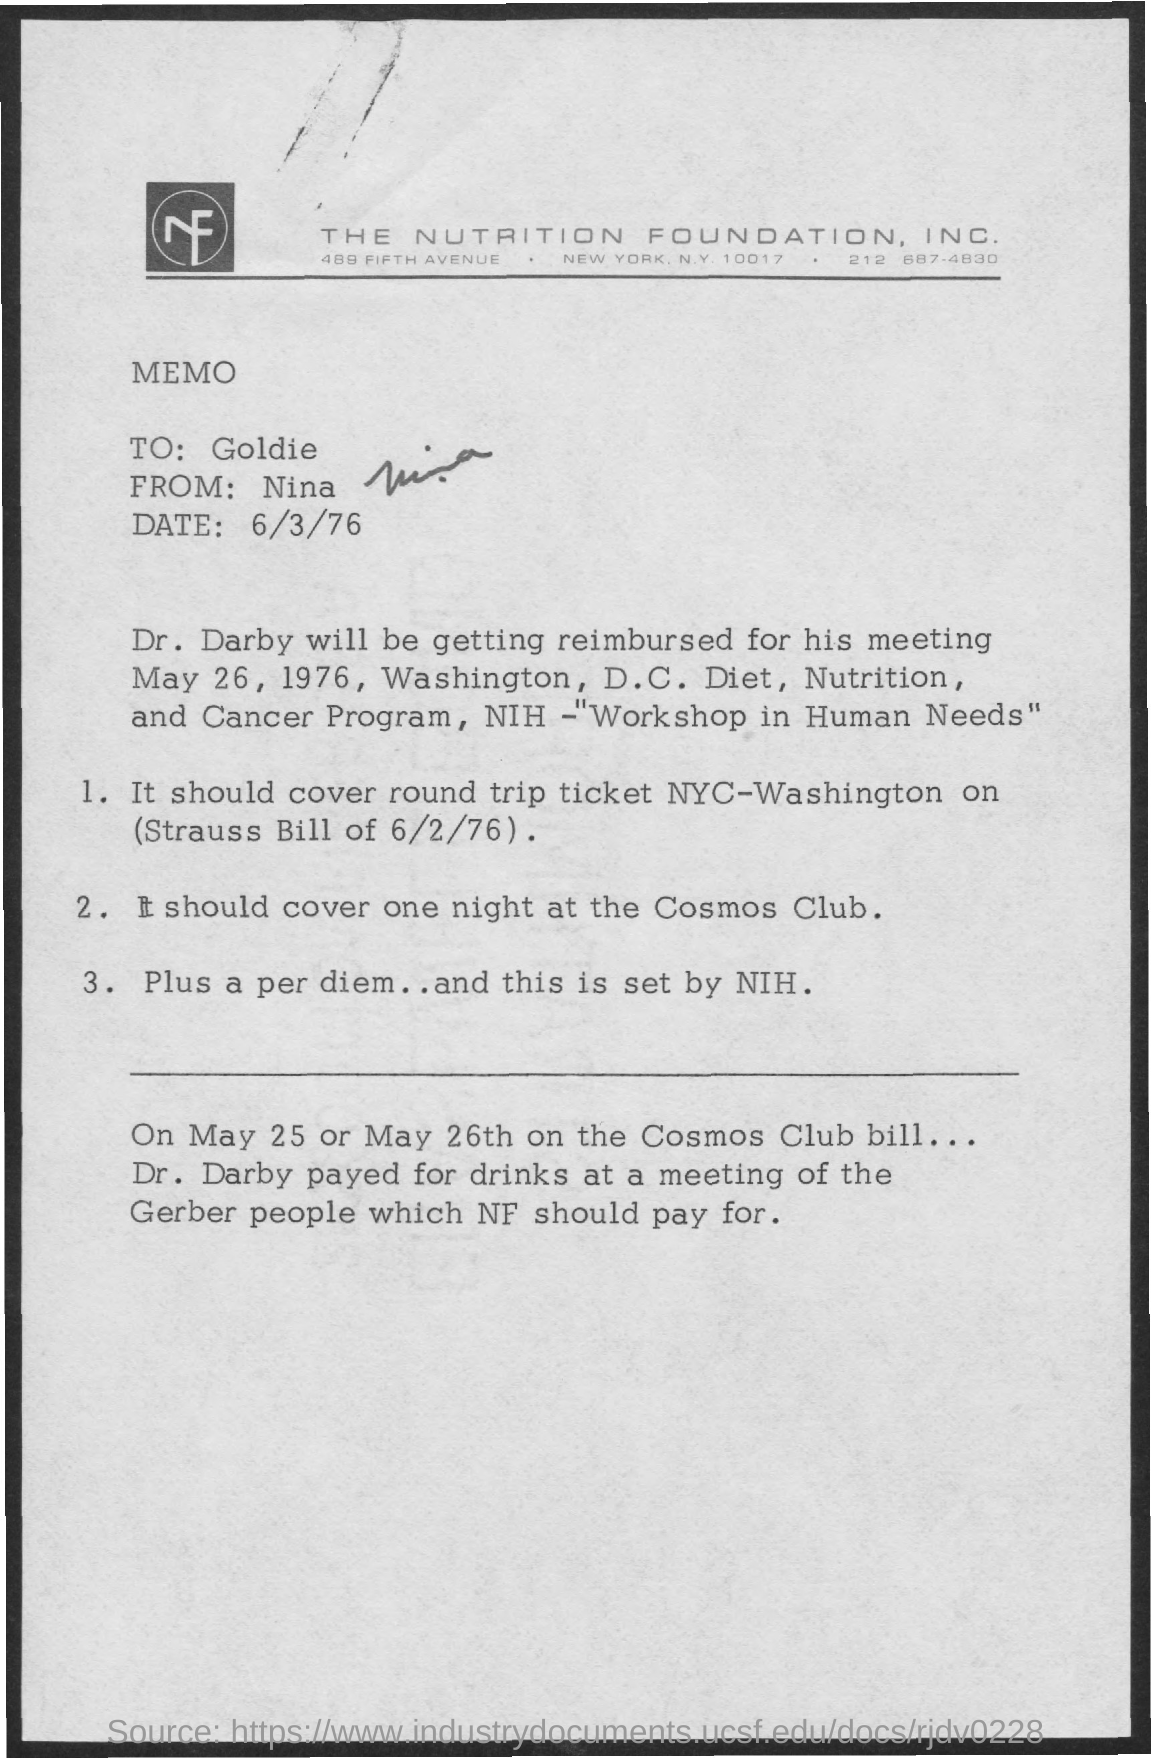List a handful of essential elements in this visual. The date mentioned at the top of the document is 6/3/76. The memorandum is addressed to Goldie. The memorandum is from Nina. 